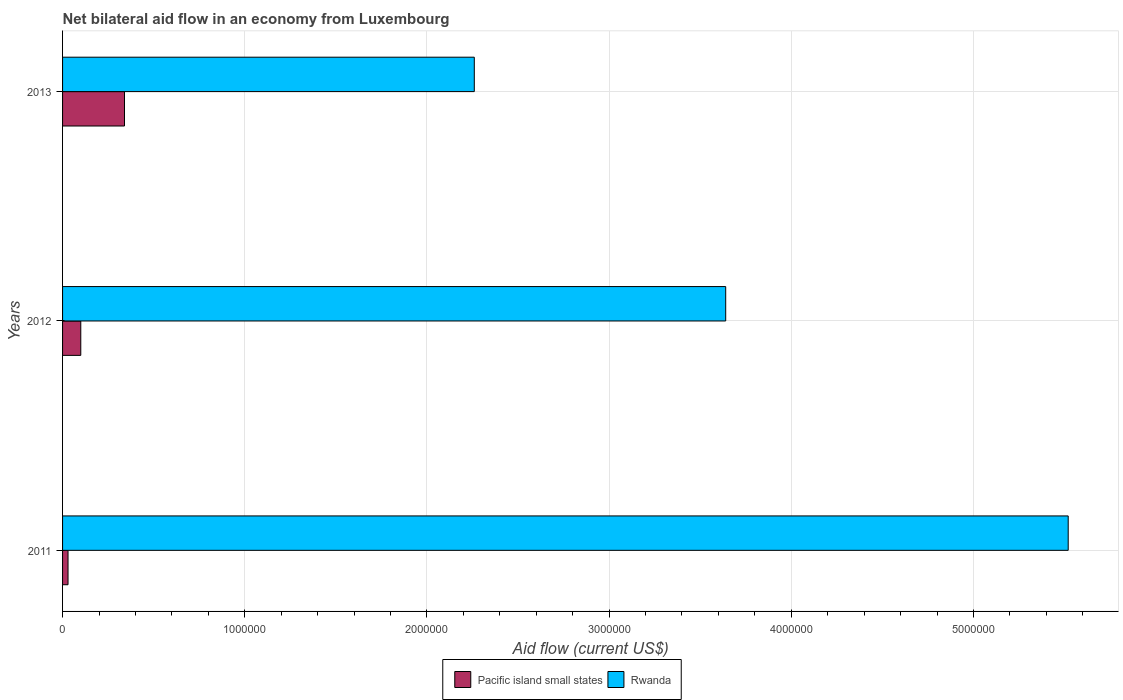How many different coloured bars are there?
Keep it short and to the point. 2. Are the number of bars per tick equal to the number of legend labels?
Provide a short and direct response. Yes. Across all years, what is the maximum net bilateral aid flow in Pacific island small states?
Your answer should be compact. 3.40e+05. Across all years, what is the minimum net bilateral aid flow in Rwanda?
Your response must be concise. 2.26e+06. In which year was the net bilateral aid flow in Rwanda minimum?
Provide a succinct answer. 2013. What is the total net bilateral aid flow in Pacific island small states in the graph?
Your answer should be compact. 4.70e+05. What is the difference between the net bilateral aid flow in Rwanda in 2011 and that in 2013?
Offer a terse response. 3.26e+06. What is the difference between the net bilateral aid flow in Rwanda in 2011 and the net bilateral aid flow in Pacific island small states in 2012?
Make the answer very short. 5.42e+06. What is the average net bilateral aid flow in Rwanda per year?
Ensure brevity in your answer.  3.81e+06. In the year 2013, what is the difference between the net bilateral aid flow in Rwanda and net bilateral aid flow in Pacific island small states?
Offer a terse response. 1.92e+06. In how many years, is the net bilateral aid flow in Pacific island small states greater than 3000000 US$?
Your answer should be very brief. 0. What is the ratio of the net bilateral aid flow in Rwanda in 2012 to that in 2013?
Your answer should be compact. 1.61. Is the difference between the net bilateral aid flow in Rwanda in 2011 and 2013 greater than the difference between the net bilateral aid flow in Pacific island small states in 2011 and 2013?
Provide a succinct answer. Yes. What is the difference between the highest and the second highest net bilateral aid flow in Rwanda?
Make the answer very short. 1.88e+06. What is the difference between the highest and the lowest net bilateral aid flow in Rwanda?
Provide a succinct answer. 3.26e+06. What does the 1st bar from the top in 2013 represents?
Ensure brevity in your answer.  Rwanda. What does the 2nd bar from the bottom in 2011 represents?
Offer a very short reply. Rwanda. How many bars are there?
Provide a short and direct response. 6. Are the values on the major ticks of X-axis written in scientific E-notation?
Keep it short and to the point. No. Does the graph contain grids?
Provide a succinct answer. Yes. What is the title of the graph?
Make the answer very short. Net bilateral aid flow in an economy from Luxembourg. Does "Sint Maarten (Dutch part)" appear as one of the legend labels in the graph?
Offer a very short reply. No. What is the label or title of the Y-axis?
Your answer should be compact. Years. What is the Aid flow (current US$) of Rwanda in 2011?
Ensure brevity in your answer.  5.52e+06. What is the Aid flow (current US$) in Pacific island small states in 2012?
Keep it short and to the point. 1.00e+05. What is the Aid flow (current US$) in Rwanda in 2012?
Provide a short and direct response. 3.64e+06. What is the Aid flow (current US$) of Rwanda in 2013?
Your response must be concise. 2.26e+06. Across all years, what is the maximum Aid flow (current US$) in Rwanda?
Make the answer very short. 5.52e+06. Across all years, what is the minimum Aid flow (current US$) of Pacific island small states?
Your answer should be very brief. 3.00e+04. Across all years, what is the minimum Aid flow (current US$) in Rwanda?
Your response must be concise. 2.26e+06. What is the total Aid flow (current US$) of Pacific island small states in the graph?
Provide a short and direct response. 4.70e+05. What is the total Aid flow (current US$) in Rwanda in the graph?
Your response must be concise. 1.14e+07. What is the difference between the Aid flow (current US$) in Pacific island small states in 2011 and that in 2012?
Your answer should be compact. -7.00e+04. What is the difference between the Aid flow (current US$) of Rwanda in 2011 and that in 2012?
Provide a succinct answer. 1.88e+06. What is the difference between the Aid flow (current US$) in Pacific island small states in 2011 and that in 2013?
Keep it short and to the point. -3.10e+05. What is the difference between the Aid flow (current US$) of Rwanda in 2011 and that in 2013?
Offer a very short reply. 3.26e+06. What is the difference between the Aid flow (current US$) in Rwanda in 2012 and that in 2013?
Provide a short and direct response. 1.38e+06. What is the difference between the Aid flow (current US$) in Pacific island small states in 2011 and the Aid flow (current US$) in Rwanda in 2012?
Offer a very short reply. -3.61e+06. What is the difference between the Aid flow (current US$) of Pacific island small states in 2011 and the Aid flow (current US$) of Rwanda in 2013?
Your answer should be compact. -2.23e+06. What is the difference between the Aid flow (current US$) of Pacific island small states in 2012 and the Aid flow (current US$) of Rwanda in 2013?
Provide a succinct answer. -2.16e+06. What is the average Aid flow (current US$) in Pacific island small states per year?
Your answer should be very brief. 1.57e+05. What is the average Aid flow (current US$) in Rwanda per year?
Make the answer very short. 3.81e+06. In the year 2011, what is the difference between the Aid flow (current US$) of Pacific island small states and Aid flow (current US$) of Rwanda?
Make the answer very short. -5.49e+06. In the year 2012, what is the difference between the Aid flow (current US$) of Pacific island small states and Aid flow (current US$) of Rwanda?
Your answer should be very brief. -3.54e+06. In the year 2013, what is the difference between the Aid flow (current US$) in Pacific island small states and Aid flow (current US$) in Rwanda?
Give a very brief answer. -1.92e+06. What is the ratio of the Aid flow (current US$) of Pacific island small states in 2011 to that in 2012?
Provide a succinct answer. 0.3. What is the ratio of the Aid flow (current US$) of Rwanda in 2011 to that in 2012?
Offer a very short reply. 1.52. What is the ratio of the Aid flow (current US$) of Pacific island small states in 2011 to that in 2013?
Ensure brevity in your answer.  0.09. What is the ratio of the Aid flow (current US$) in Rwanda in 2011 to that in 2013?
Provide a short and direct response. 2.44. What is the ratio of the Aid flow (current US$) of Pacific island small states in 2012 to that in 2013?
Ensure brevity in your answer.  0.29. What is the ratio of the Aid flow (current US$) in Rwanda in 2012 to that in 2013?
Give a very brief answer. 1.61. What is the difference between the highest and the second highest Aid flow (current US$) in Rwanda?
Ensure brevity in your answer.  1.88e+06. What is the difference between the highest and the lowest Aid flow (current US$) in Pacific island small states?
Offer a very short reply. 3.10e+05. What is the difference between the highest and the lowest Aid flow (current US$) in Rwanda?
Provide a short and direct response. 3.26e+06. 